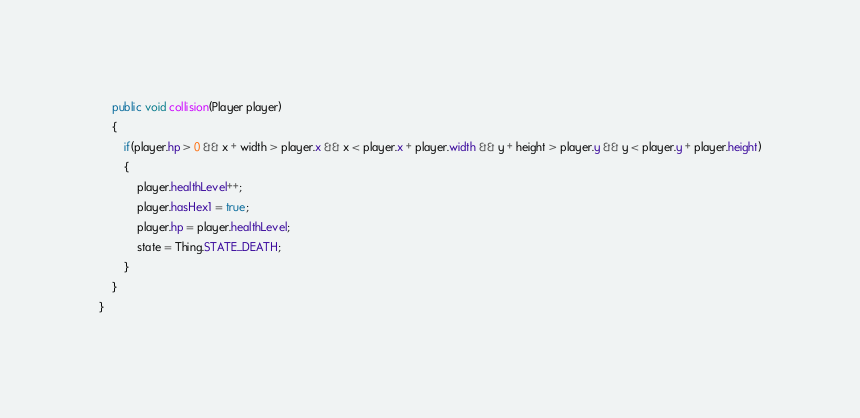<code> <loc_0><loc_0><loc_500><loc_500><_Java_>
    public void collision(Player player)
    {
        if(player.hp > 0 && x + width > player.x && x < player.x + player.width && y + height > player.y && y < player.y + player.height)
        {
            player.healthLevel++;
            player.hasHex1 = true;
            player.hp = player.healthLevel;
            state = Thing.STATE_DEATH;
        }
    }
}
</code> 